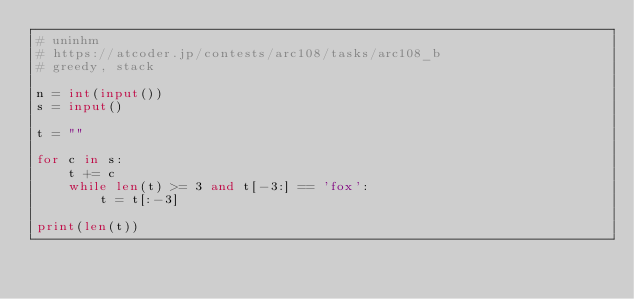<code> <loc_0><loc_0><loc_500><loc_500><_Python_># uninhm
# https://atcoder.jp/contests/arc108/tasks/arc108_b
# greedy, stack

n = int(input())
s = input()

t = ""

for c in s:
    t += c
    while len(t) >= 3 and t[-3:] == 'fox':
        t = t[:-3]

print(len(t))
</code> 